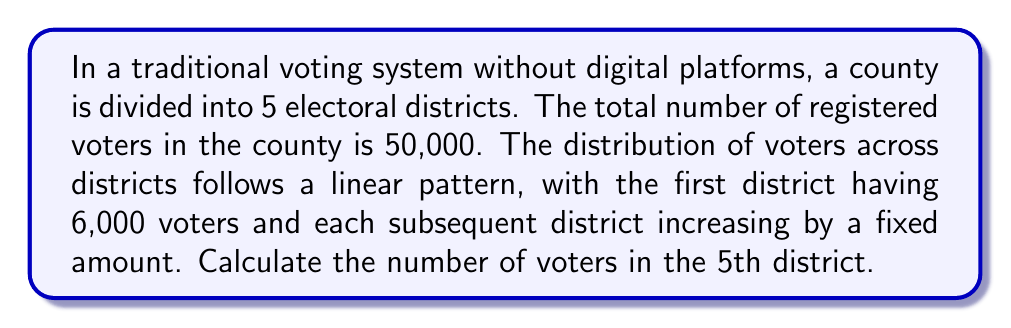Could you help me with this problem? Let's approach this step-by-step:

1) Let $x$ be the fixed increase in voters between each district.

2) We can represent the number of voters in each district as:
   District 1: 6,000
   District 2: 6,000 + x
   District 3: 6,000 + 2x
   District 4: 6,000 + 3x
   District 5: 6,000 + 4x

3) The sum of all districts should equal the total number of voters:

   $$(6,000) + (6,000 + x) + (6,000 + 2x) + (6,000 + 3x) + (6,000 + 4x) = 50,000$$

4) Simplify the left side of the equation:

   $$30,000 + 10x = 50,000$$

5) Subtract 30,000 from both sides:

   $$10x = 20,000$$

6) Divide both sides by 10:

   $$x = 2,000$$

7) Therefore, each district increases by 2,000 voters.

8) The 5th district is represented by $6,000 + 4x$. Substitute $x = 2,000$:

   $$6,000 + 4(2,000) = 6,000 + 8,000 = 14,000$$

Thus, the 5th district has 14,000 voters.
Answer: 14,000 voters 